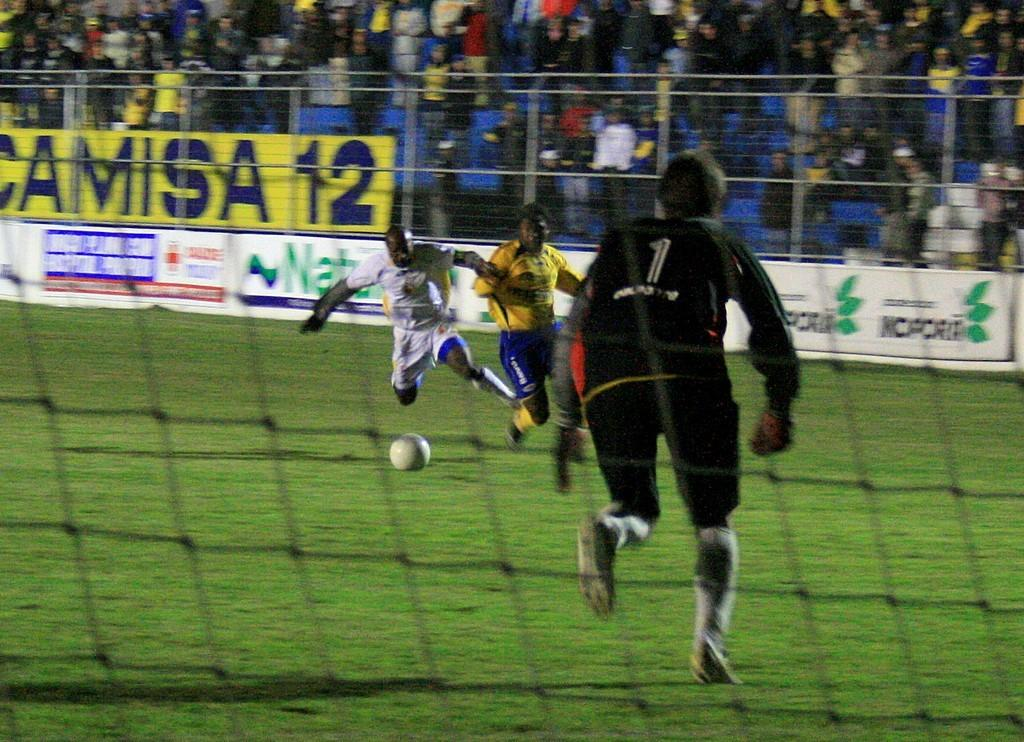<image>
Summarize the visual content of the image. soccer players fight for a ball in front of ads for Camisa 12 